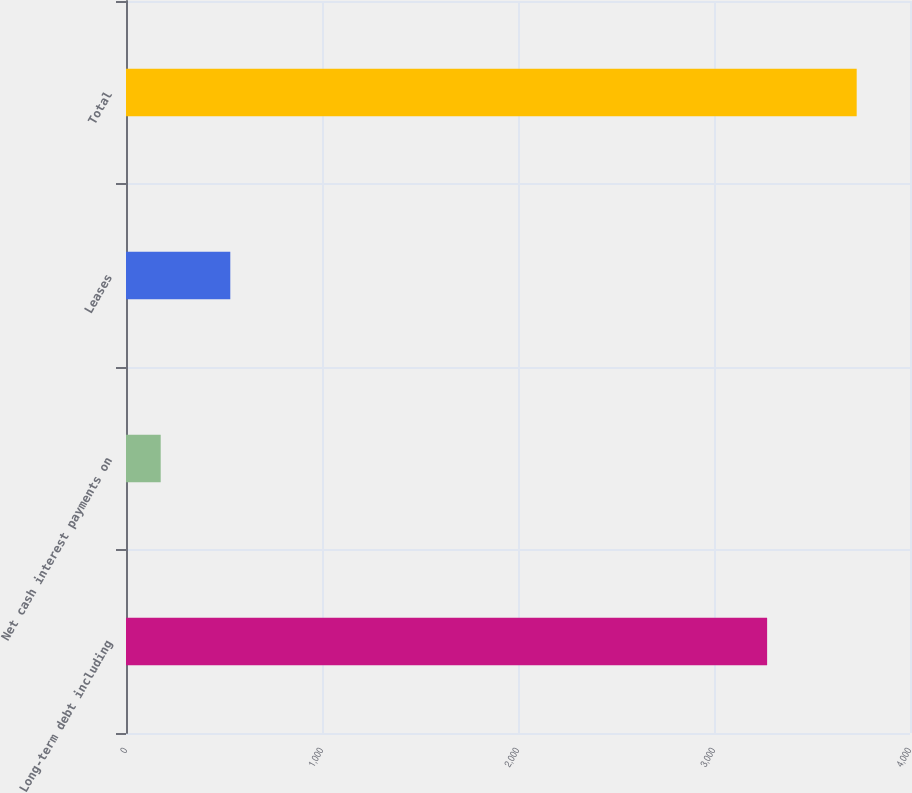<chart> <loc_0><loc_0><loc_500><loc_500><bar_chart><fcel>Long-term debt including<fcel>Net cash interest payments on<fcel>Leases<fcel>Total<nl><fcel>3271<fcel>177<fcel>532.1<fcel>3728<nl></chart> 